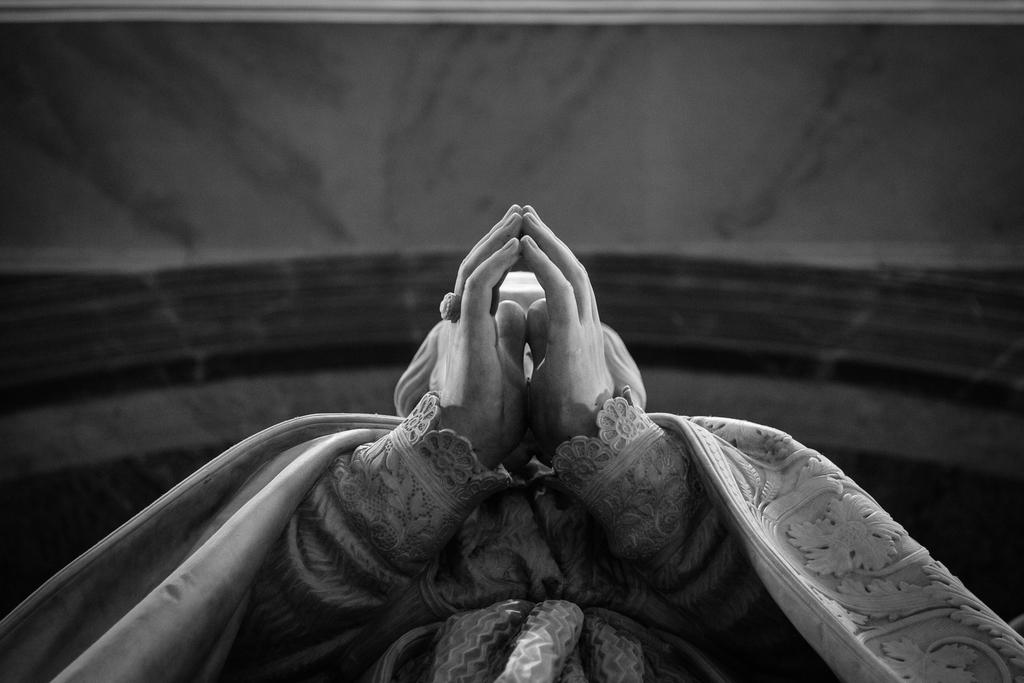What is the main subject of the image? There is a sculpture in the image. From where was the image taken? The image is taken from beneath the sculpture. What part of the sculpture can be seen in the image? Only the hands part of the sculpture is visible. What is the color scheme of the image? The image is black and white. What type of scarecrow can be seen holding straw in the image? There is no scarecrow or straw present in the image; it features a sculpture with only the hands visible. How many pies are visible on the ground near the sculpture in the image? There are no pies visible in the image; it only shows the hands part of the sculpture. 